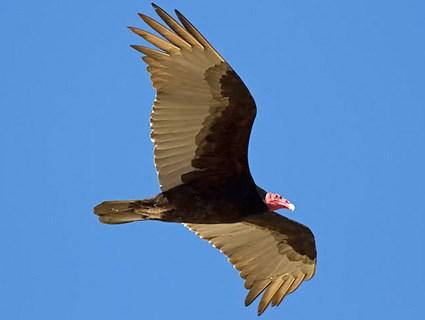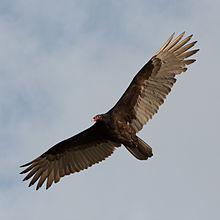The first image is the image on the left, the second image is the image on the right. Evaluate the accuracy of this statement regarding the images: "All of the birds are flying.". Is it true? Answer yes or no. Yes. The first image is the image on the left, the second image is the image on the right. Assess this claim about the two images: "The bird on the right image is facing right.". Correct or not? Answer yes or no. No. 